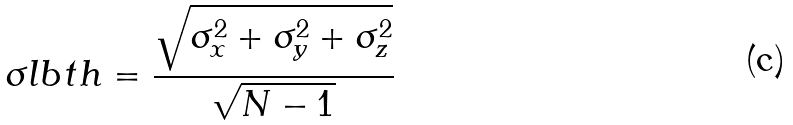Convert formula to latex. <formula><loc_0><loc_0><loc_500><loc_500>\sigma l b t h = \frac { \sqrt { \sigma _ { x } ^ { 2 } + \sigma _ { y } ^ { 2 } + \sigma _ { z } ^ { 2 } } } { \sqrt { N - 1 } }</formula> 